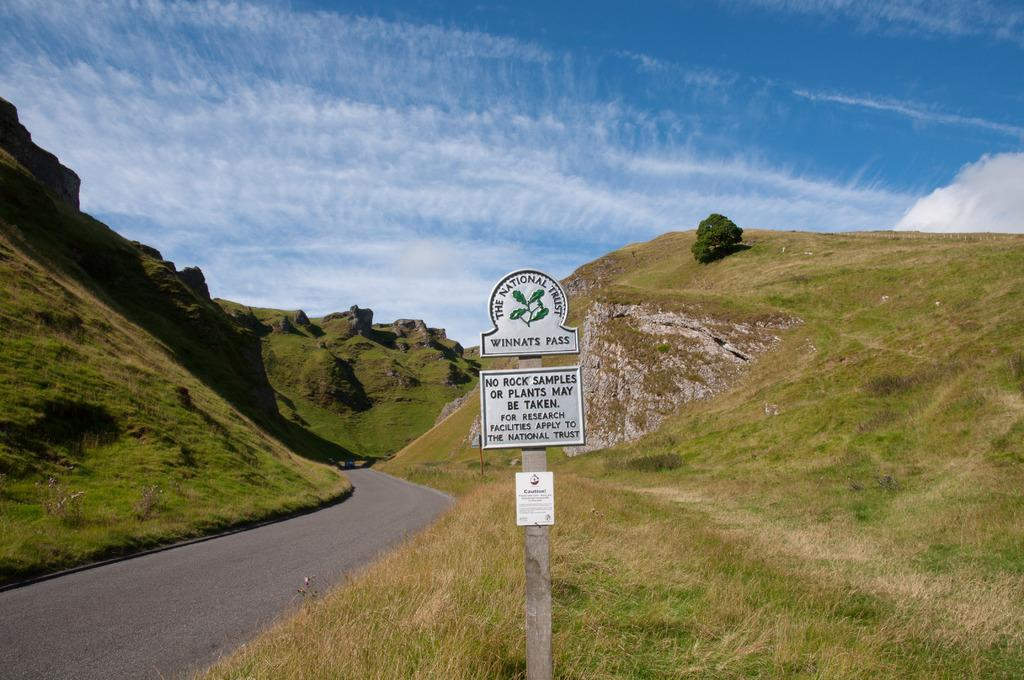What is the main feature of the image? There is a road in the image. What is the geographical setting of the road? The road is situated between mountains. Are there any plants visible in the image? Yes, there is a plant on one of the mountains. What is attached to the pole in the image? There are boards with text on a pole in the image. What can be seen in the background of the image? The sky is visible in the background of the image, and clouds are present in the sky. What type of notebook is being used by the tramp in the image? There is no tramp or notebook present in the image. How many hands are visible in the image? There is no reference to hands in the image, so it is not possible to determine how many hands are visible. 